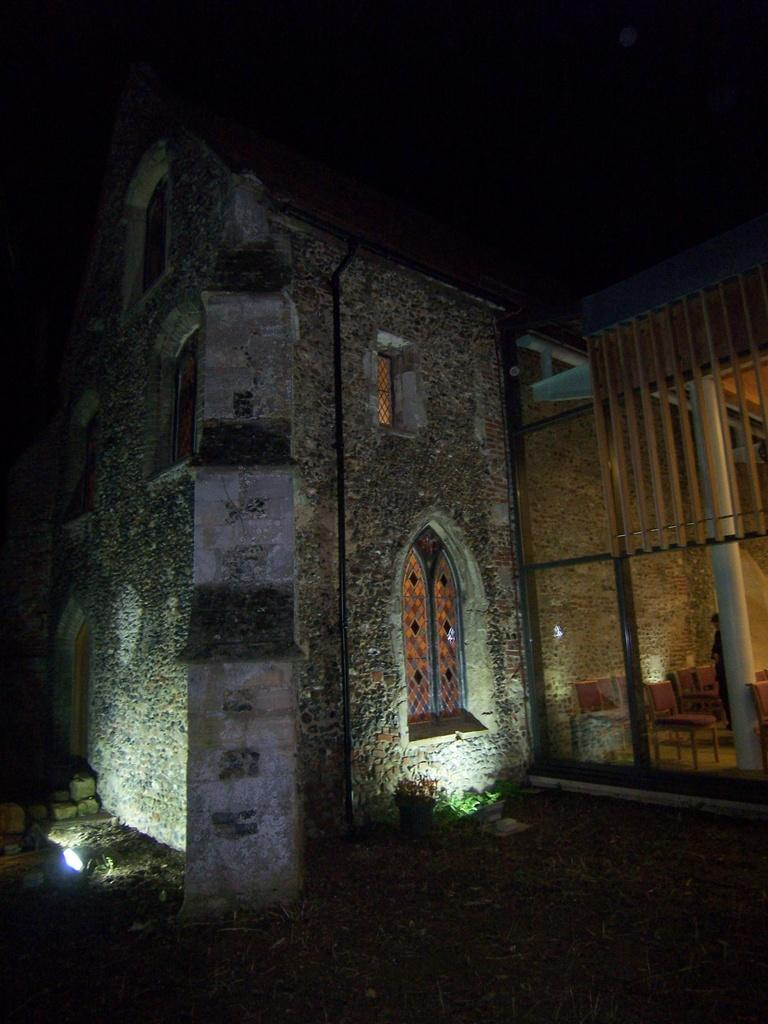What is the main structure in the image? There is a building in the image. Are there any specific features of the building? Yes, the building has two lights at the bottom. What type of spoon is being used to shovel snow in the image? There is no spoon or snow present in the image; it only features a building with two lights at the bottom. 